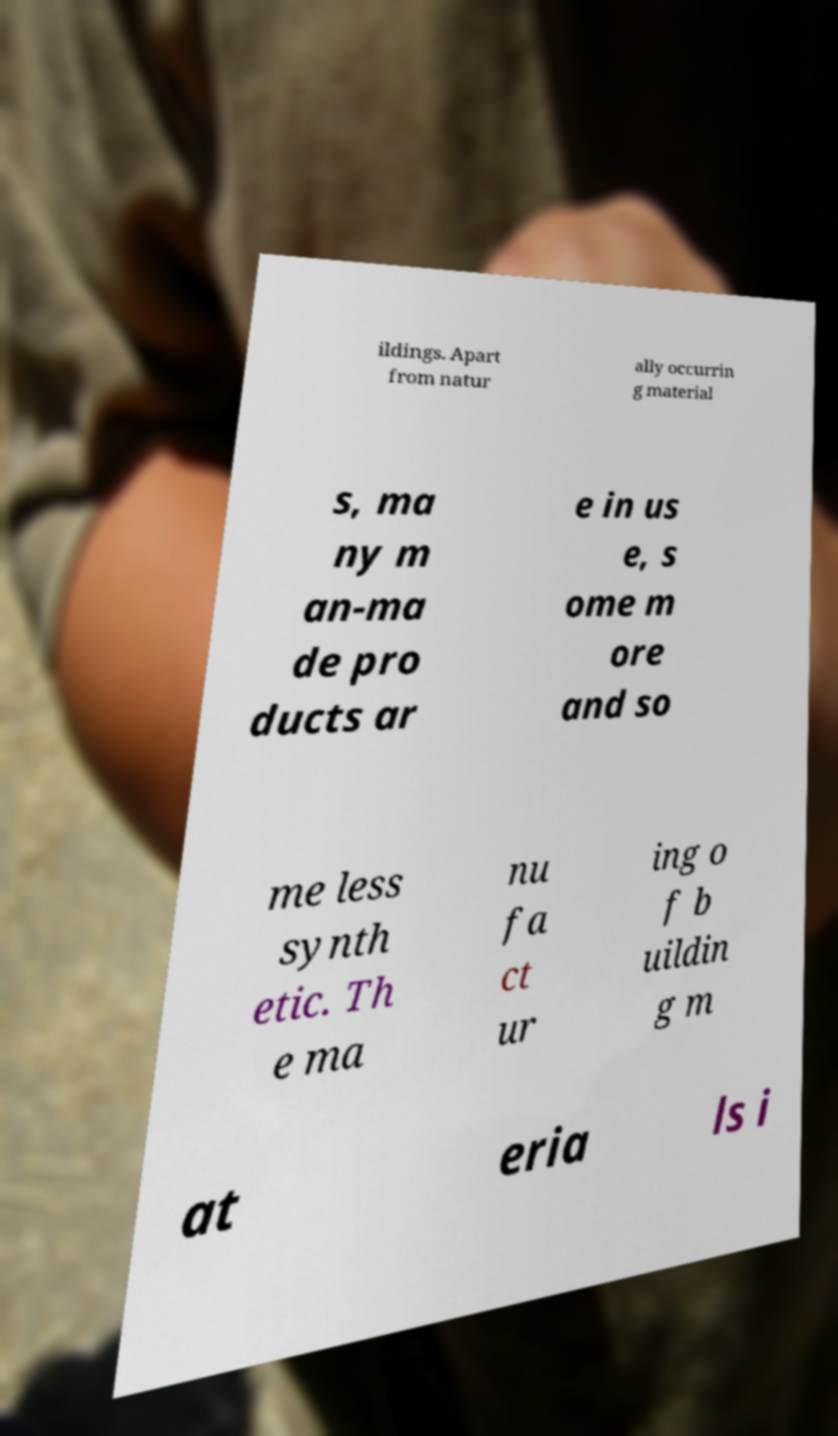Can you read and provide the text displayed in the image?This photo seems to have some interesting text. Can you extract and type it out for me? ildings. Apart from natur ally occurrin g material s, ma ny m an-ma de pro ducts ar e in us e, s ome m ore and so me less synth etic. Th e ma nu fa ct ur ing o f b uildin g m at eria ls i 